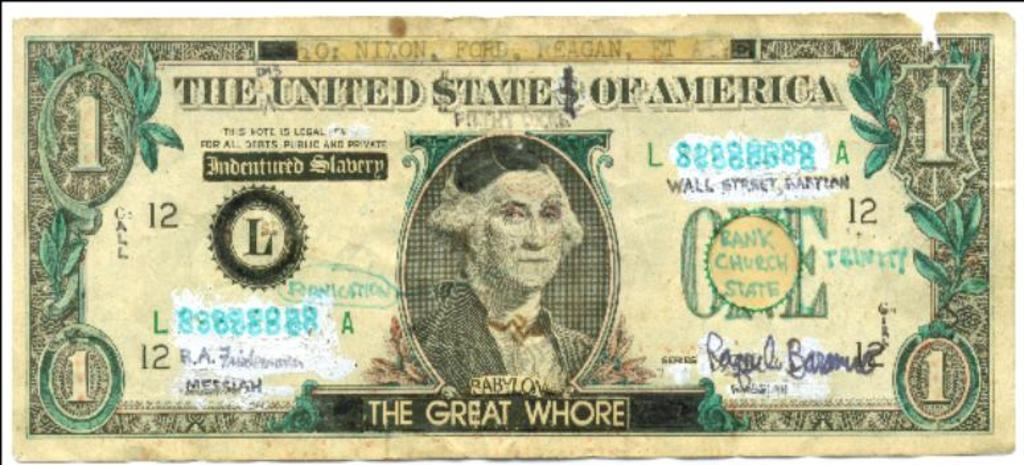<image>
Create a compact narrative representing the image presented. A US dollar bill has a black banner on the bottom that begins with, "The Great." 